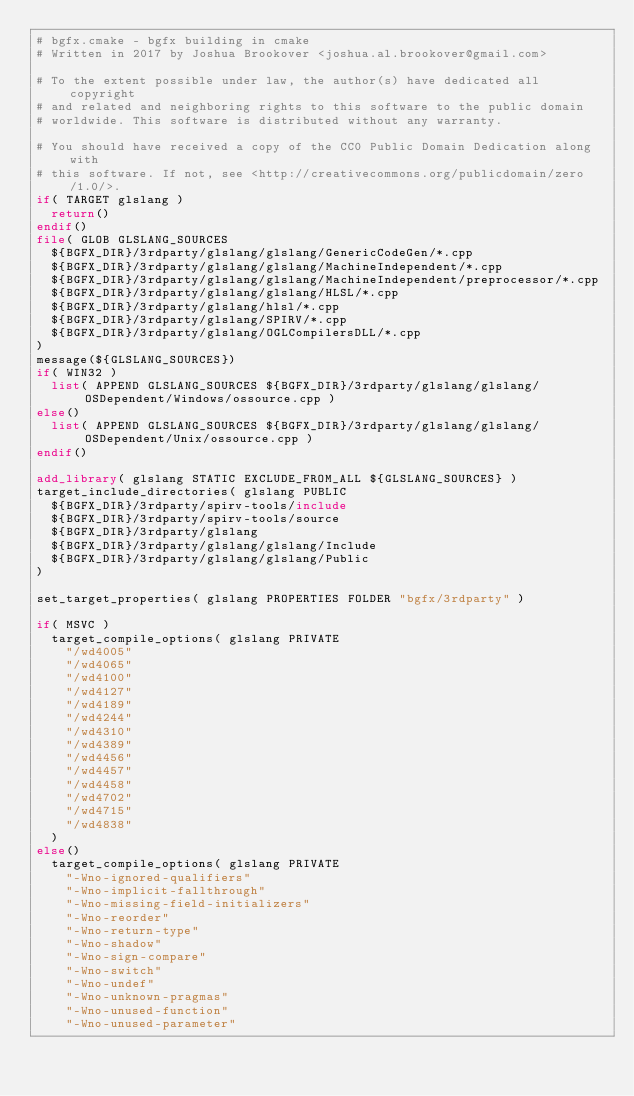<code> <loc_0><loc_0><loc_500><loc_500><_CMake_># bgfx.cmake - bgfx building in cmake
# Written in 2017 by Joshua Brookover <joshua.al.brookover@gmail.com>

# To the extent possible under law, the author(s) have dedicated all copyright
# and related and neighboring rights to this software to the public domain
# worldwide. This software is distributed without any warranty.

# You should have received a copy of the CC0 Public Domain Dedication along with
# this software. If not, see <http://creativecommons.org/publicdomain/zero/1.0/>.
if( TARGET glslang )
	return()
endif()
file( GLOB GLSLANG_SOURCES
	${BGFX_DIR}/3rdparty/glslang/glslang/GenericCodeGen/*.cpp
	${BGFX_DIR}/3rdparty/glslang/glslang/MachineIndependent/*.cpp
	${BGFX_DIR}/3rdparty/glslang/glslang/MachineIndependent/preprocessor/*.cpp
	${BGFX_DIR}/3rdparty/glslang/glslang/HLSL/*.cpp
	${BGFX_DIR}/3rdparty/glslang/hlsl/*.cpp
	${BGFX_DIR}/3rdparty/glslang/SPIRV/*.cpp
	${BGFX_DIR}/3rdparty/glslang/OGLCompilersDLL/*.cpp
)
message(${GLSLANG_SOURCES})
if( WIN32 )
	list( APPEND GLSLANG_SOURCES ${BGFX_DIR}/3rdparty/glslang/glslang/OSDependent/Windows/ossource.cpp )
else()
	list( APPEND GLSLANG_SOURCES ${BGFX_DIR}/3rdparty/glslang/glslang/OSDependent/Unix/ossource.cpp )
endif()

add_library( glslang STATIC EXCLUDE_FROM_ALL ${GLSLANG_SOURCES} )
target_include_directories( glslang PUBLIC
	${BGFX_DIR}/3rdparty/spirv-tools/include
	${BGFX_DIR}/3rdparty/spirv-tools/source
	${BGFX_DIR}/3rdparty/glslang
	${BGFX_DIR}/3rdparty/glslang/glslang/Include
	${BGFX_DIR}/3rdparty/glslang/glslang/Public
)

set_target_properties( glslang PROPERTIES FOLDER "bgfx/3rdparty" )

if( MSVC )
	target_compile_options( glslang PRIVATE
		"/wd4005"
		"/wd4065"
		"/wd4100"
		"/wd4127"
		"/wd4189"
		"/wd4244"
		"/wd4310"
		"/wd4389"
		"/wd4456"
		"/wd4457"
		"/wd4458"
		"/wd4702"
		"/wd4715"
		"/wd4838"
	)
else()
	target_compile_options( glslang PRIVATE
		"-Wno-ignored-qualifiers"
		"-Wno-implicit-fallthrough"
		"-Wno-missing-field-initializers"
		"-Wno-reorder"
		"-Wno-return-type"
		"-Wno-shadow"
		"-Wno-sign-compare"
		"-Wno-switch"
		"-Wno-undef"
		"-Wno-unknown-pragmas"
		"-Wno-unused-function"
		"-Wno-unused-parameter"</code> 